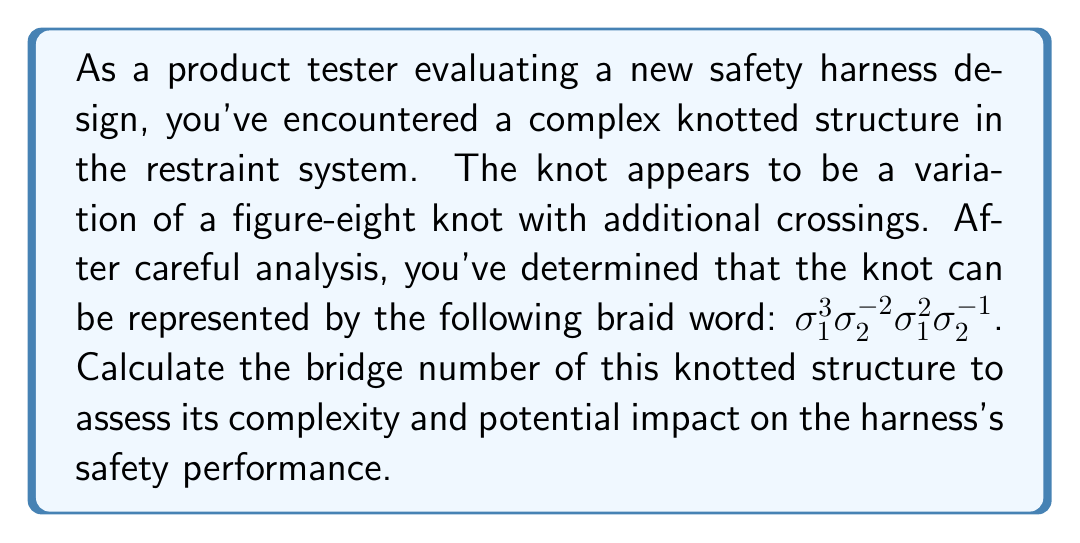Help me with this question. To compute the bridge number of the knotted structure, we'll follow these steps:

1. First, recall that the bridge number of a knot is the minimum number of bridges needed in any bridge presentation of the knot.

2. For a knot given in braid form, the bridge number is at most the number of strands in the braid. In this case, we have a 3-strand braid (as the indices in $\sigma_i$ go up to 2).

3. To determine if we can reduce the bridge number, we need to analyze the braid word:
   $\sigma_1^3 \sigma_2^{-2} \sigma_1^2 \sigma_2^{-1}$

4. This braid word doesn't simplify to a trivial knot or a 2-bridge knot (which would have a bridge number of 2).

5. The complexity of the braid word suggests that it's likely a non-trivial 3-bridge knot.

6. To confirm this, we could attempt to find a bridge presentation with fewer than 3 bridges, but the structure of the braid makes this unlikely.

7. Therefore, based on the given information and the complexity of the braid word, we can conclude that the bridge number of this knotted structure is 3.

This bridge number indicates a moderately complex knot, which could potentially affect the safety harness's performance and ease of use. As a product tester, you should consider how this complexity might impact factors such as ease of adjustment, potential for tangling, and overall reliability of the restraint system.
Answer: 3 